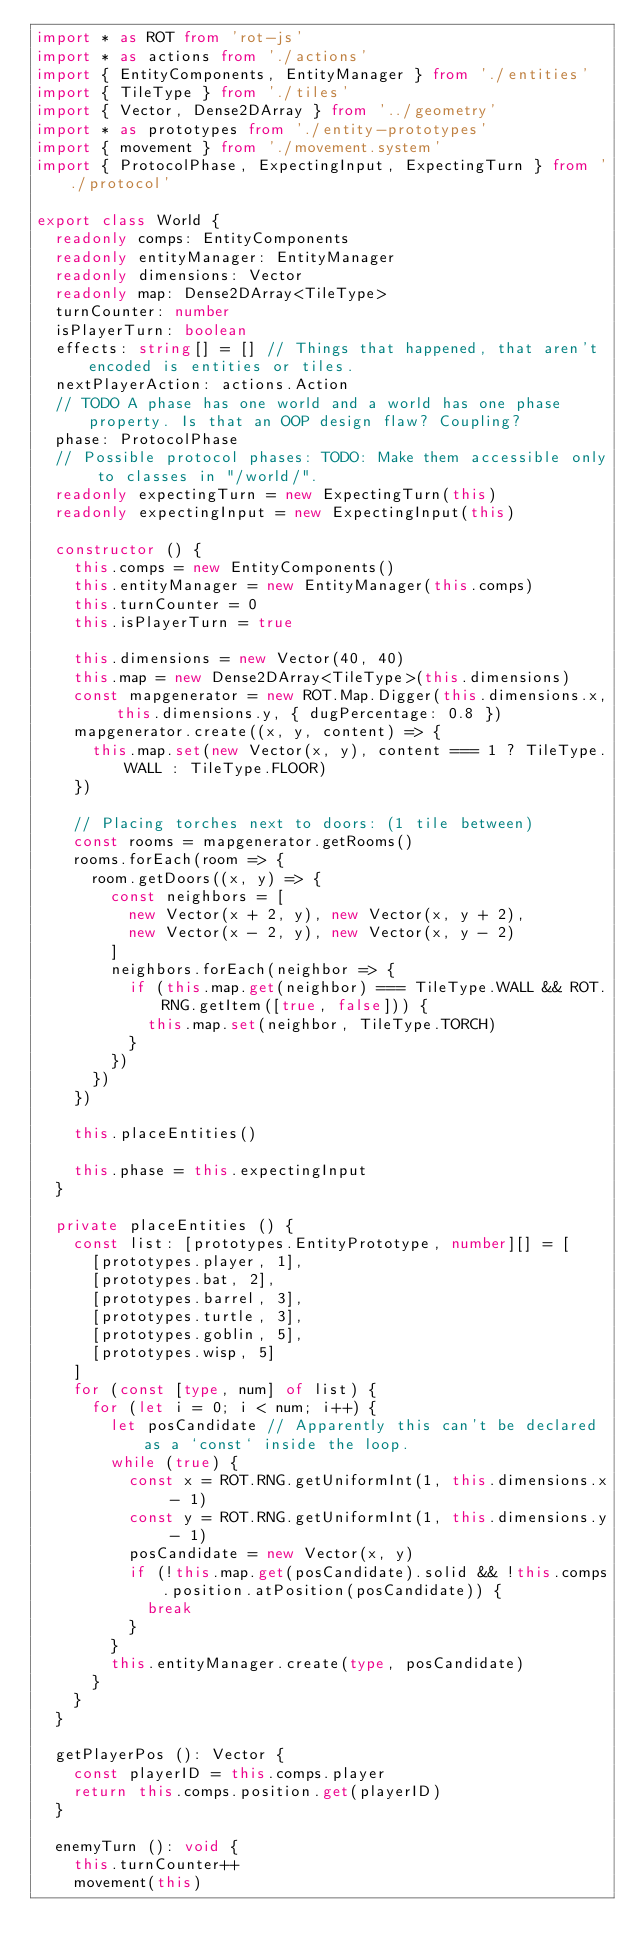Convert code to text. <code><loc_0><loc_0><loc_500><loc_500><_TypeScript_>import * as ROT from 'rot-js'
import * as actions from './actions'
import { EntityComponents, EntityManager } from './entities'
import { TileType } from './tiles'
import { Vector, Dense2DArray } from '../geometry'
import * as prototypes from './entity-prototypes'
import { movement } from './movement.system'
import { ProtocolPhase, ExpectingInput, ExpectingTurn } from './protocol'

export class World {
  readonly comps: EntityComponents
  readonly entityManager: EntityManager
  readonly dimensions: Vector
  readonly map: Dense2DArray<TileType>
  turnCounter: number
  isPlayerTurn: boolean
  effects: string[] = [] // Things that happened, that aren't encoded is entities or tiles.
  nextPlayerAction: actions.Action
  // TODO A phase has one world and a world has one phase property. Is that an OOP design flaw? Coupling?
  phase: ProtocolPhase
  // Possible protocol phases: TODO: Make them accessible only to classes in "/world/".
  readonly expectingTurn = new ExpectingTurn(this)
  readonly expectingInput = new ExpectingInput(this)

  constructor () {
    this.comps = new EntityComponents()
    this.entityManager = new EntityManager(this.comps)
    this.turnCounter = 0
    this.isPlayerTurn = true

    this.dimensions = new Vector(40, 40)
    this.map = new Dense2DArray<TileType>(this.dimensions)
    const mapgenerator = new ROT.Map.Digger(this.dimensions.x, this.dimensions.y, { dugPercentage: 0.8 })
    mapgenerator.create((x, y, content) => {
      this.map.set(new Vector(x, y), content === 1 ? TileType.WALL : TileType.FLOOR)
    })

    // Placing torches next to doors: (1 tile between)
    const rooms = mapgenerator.getRooms()
    rooms.forEach(room => {
      room.getDoors((x, y) => {
        const neighbors = [
          new Vector(x + 2, y), new Vector(x, y + 2),
          new Vector(x - 2, y), new Vector(x, y - 2)
        ]
        neighbors.forEach(neighbor => {
          if (this.map.get(neighbor) === TileType.WALL && ROT.RNG.getItem([true, false])) {
            this.map.set(neighbor, TileType.TORCH)
          }
        })
      })
    })

    this.placeEntities()

    this.phase = this.expectingInput
  }

  private placeEntities () {
    const list: [prototypes.EntityPrototype, number][] = [
      [prototypes.player, 1],
      [prototypes.bat, 2],
      [prototypes.barrel, 3],
      [prototypes.turtle, 3],
      [prototypes.goblin, 5],
      [prototypes.wisp, 5]
    ]
    for (const [type, num] of list) {
      for (let i = 0; i < num; i++) {
        let posCandidate // Apparently this can't be declared as a `const` inside the loop.
        while (true) {
          const x = ROT.RNG.getUniformInt(1, this.dimensions.x - 1)
          const y = ROT.RNG.getUniformInt(1, this.dimensions.y - 1)
          posCandidate = new Vector(x, y)
          if (!this.map.get(posCandidate).solid && !this.comps.position.atPosition(posCandidate)) {
            break
          }
        }
        this.entityManager.create(type, posCandidate)
      }
    }
  }

  getPlayerPos (): Vector {
    const playerID = this.comps.player
    return this.comps.position.get(playerID)
  }

  enemyTurn (): void {
    this.turnCounter++
    movement(this)</code> 